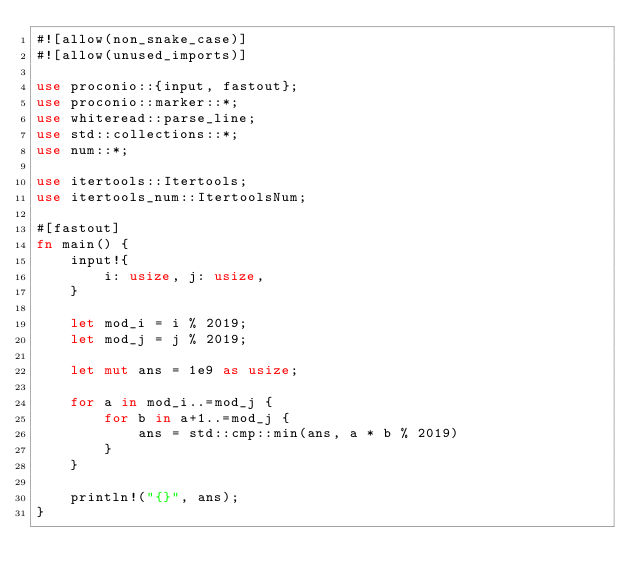<code> <loc_0><loc_0><loc_500><loc_500><_Rust_>#![allow(non_snake_case)]
#![allow(unused_imports)]

use proconio::{input, fastout};
use proconio::marker::*;
use whiteread::parse_line;
use std::collections::*;
use num::*;

use itertools::Itertools;
use itertools_num::ItertoolsNum;

#[fastout]
fn main() {
    input!{
        i: usize, j: usize,
    }

    let mod_i = i % 2019;
    let mod_j = j % 2019;

    let mut ans = 1e9 as usize;

    for a in mod_i..=mod_j {
        for b in a+1..=mod_j {
            ans = std::cmp::min(ans, a * b % 2019)
        }
    }

    println!("{}", ans);
}
</code> 